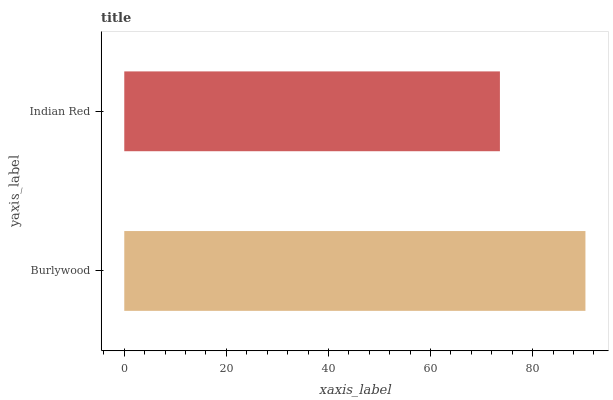Is Indian Red the minimum?
Answer yes or no. Yes. Is Burlywood the maximum?
Answer yes or no. Yes. Is Indian Red the maximum?
Answer yes or no. No. Is Burlywood greater than Indian Red?
Answer yes or no. Yes. Is Indian Red less than Burlywood?
Answer yes or no. Yes. Is Indian Red greater than Burlywood?
Answer yes or no. No. Is Burlywood less than Indian Red?
Answer yes or no. No. Is Burlywood the high median?
Answer yes or no. Yes. Is Indian Red the low median?
Answer yes or no. Yes. Is Indian Red the high median?
Answer yes or no. No. Is Burlywood the low median?
Answer yes or no. No. 